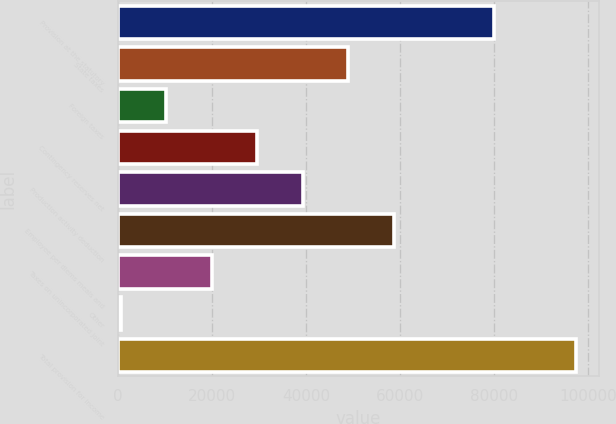Convert chart. <chart><loc_0><loc_0><loc_500><loc_500><bar_chart><fcel>Provision at the statutory<fcel>State taxes<fcel>Foreign taxes<fcel>Contingency reserves net<fcel>Production activity deduction<fcel>Employee per diems meals and<fcel>Taxes on unincorporated joint<fcel>Other<fcel>Total provision for income<nl><fcel>80036<fcel>49009.5<fcel>10239.5<fcel>29624.5<fcel>39317<fcel>58702<fcel>19932<fcel>547<fcel>97472<nl></chart> 